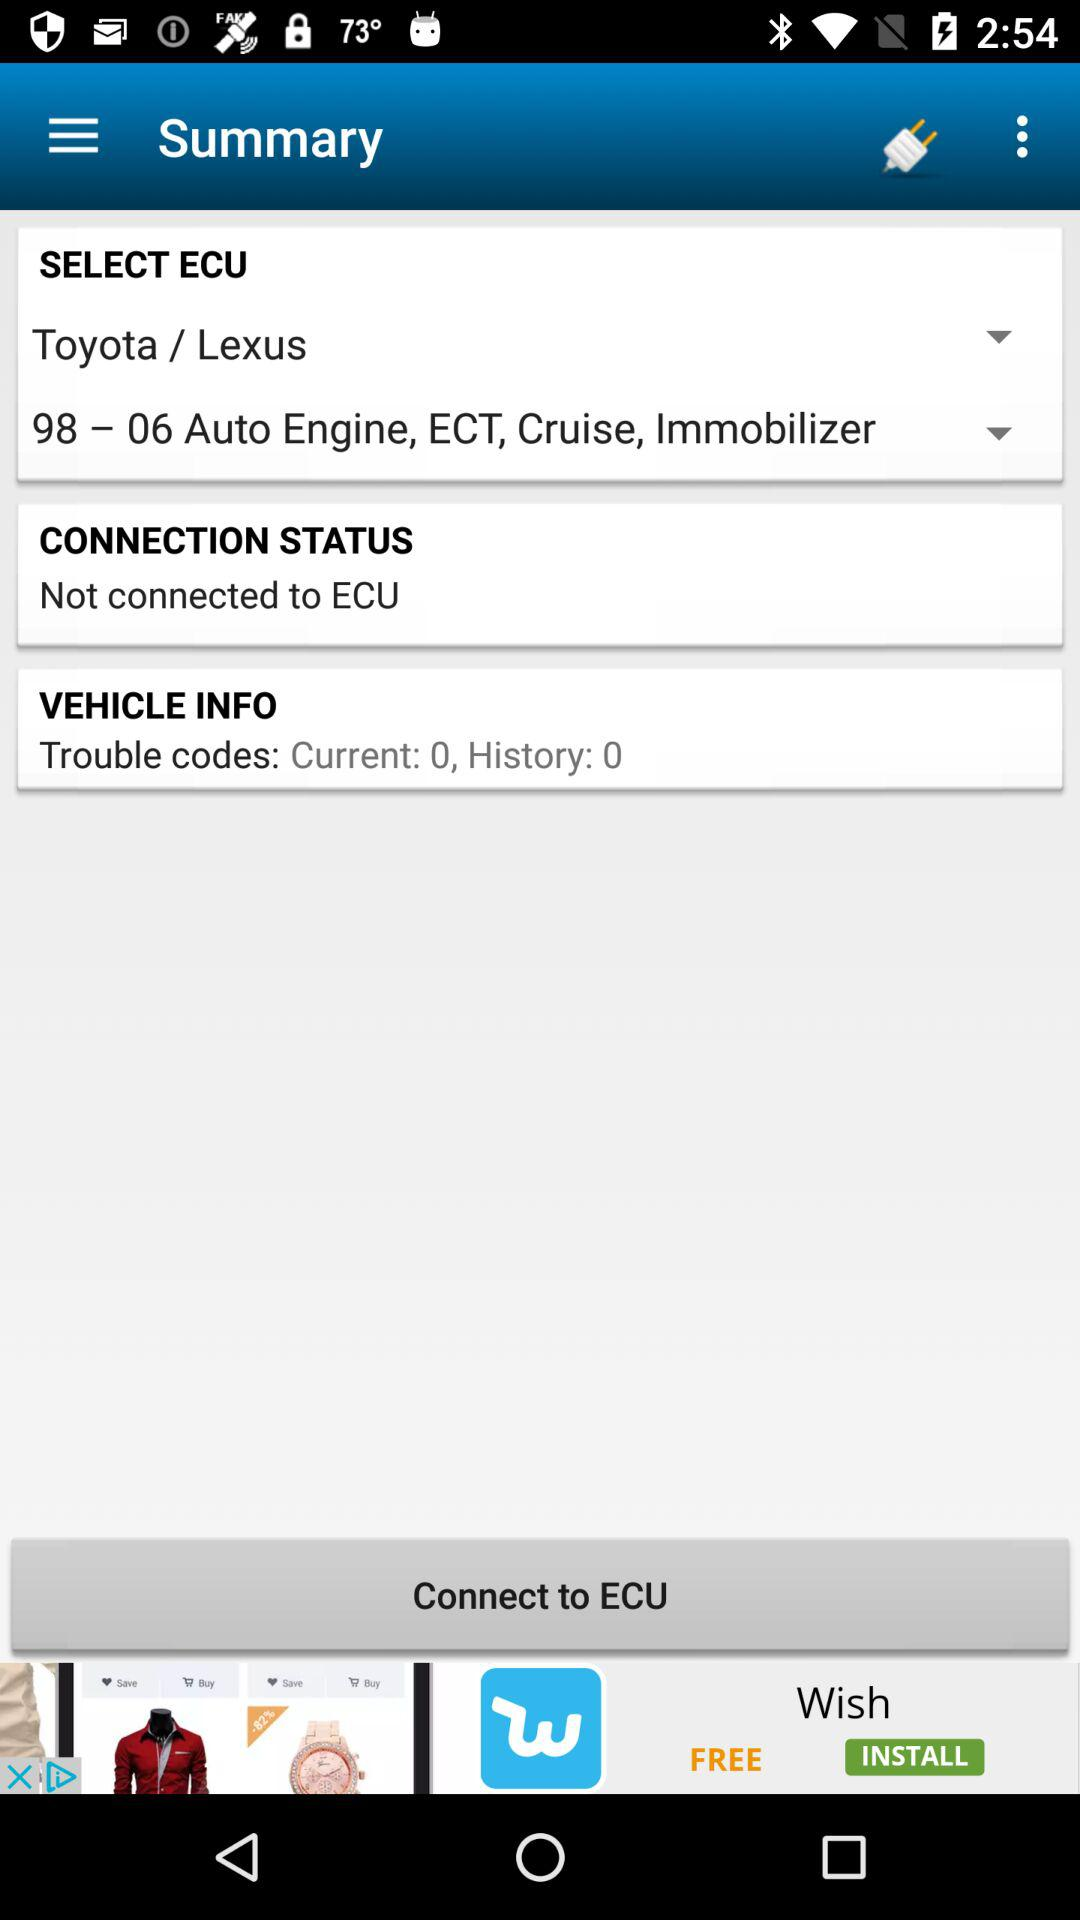What is the selected ECU? The selected ECU is 98 – 06 Auto Engine, ECT, Cruise, Immobilizer. 